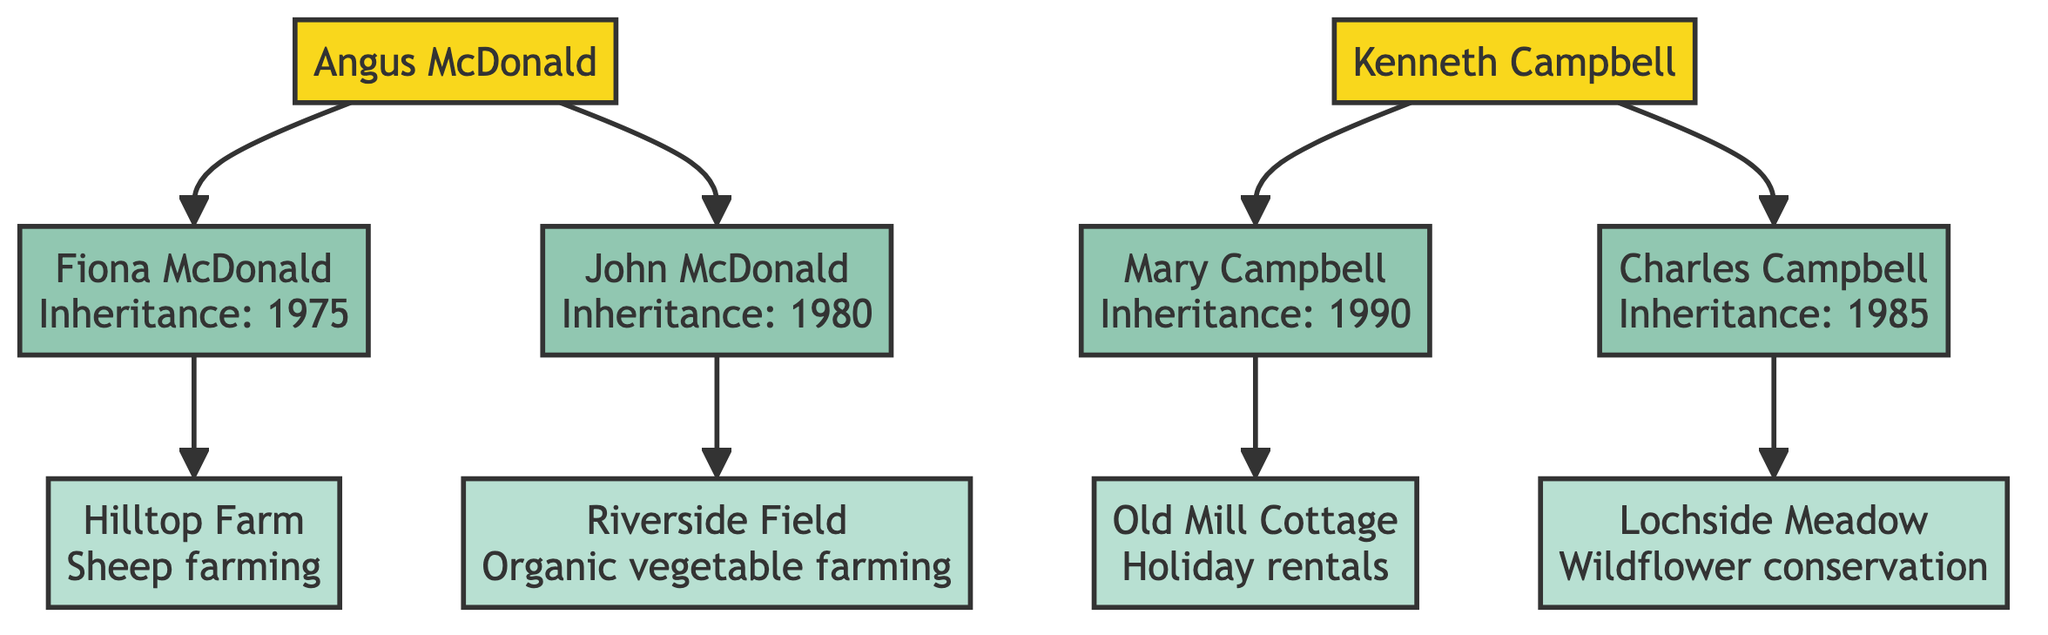What is the original owner of Hilltop Farm? The diagram shows that Hilltop Farm is connected to Angus McDonald, indicating he was the original owner of the plot.
Answer: Angus McDonald Who inherited Riverside Field? The diagram states that Riverside Field is connected to John McDonald, indicating that he is the one who inherited it.
Answer: John McDonald When was Lochside Meadow inherited? The diagram shows that Lochside Meadow is linked to Charles Campbell with the inheritance year noted as 1985.
Answer: 1985 What type of farming is currently done on Riverside Field? Riverside Field is directly connected to John McDonald, with a description indicating the current usage as organic vegetable farming.
Answer: Organic vegetable farming Which family has a plot designated for holiday rentals? Old Mill Cottage is shown connected to Mary Campbell with the current usage described as holiday rentals, indicating it is the respective family's plot for that purpose.
Answer: Campbell How many plots are connected to the McDonald family? The diagram indicates that the McDonald family has two descendants, Fiona and John McDonald, each connected to a plot, which totals two plots.
Answer: 2 Which land reform event occurred in 1960? The diagram includes a historical event section, listing the land reform act occurring in 1960, with the note on redistribution of land.
Answer: Land reform act What is the historical significance of Lochside Meadow? The diagram states that Lochside Meadow was dedicated to conservation in the mid-1980s, marking its historical importance for wildflower conservation.
Answer: Dedicated to conservation Which family has maintained sheep farming? Fiona McDonald is shown connected to Hilltop Farm, which is currently used for sheep farming, indicating her family's sustained farming practice.
Answer: McDonald 